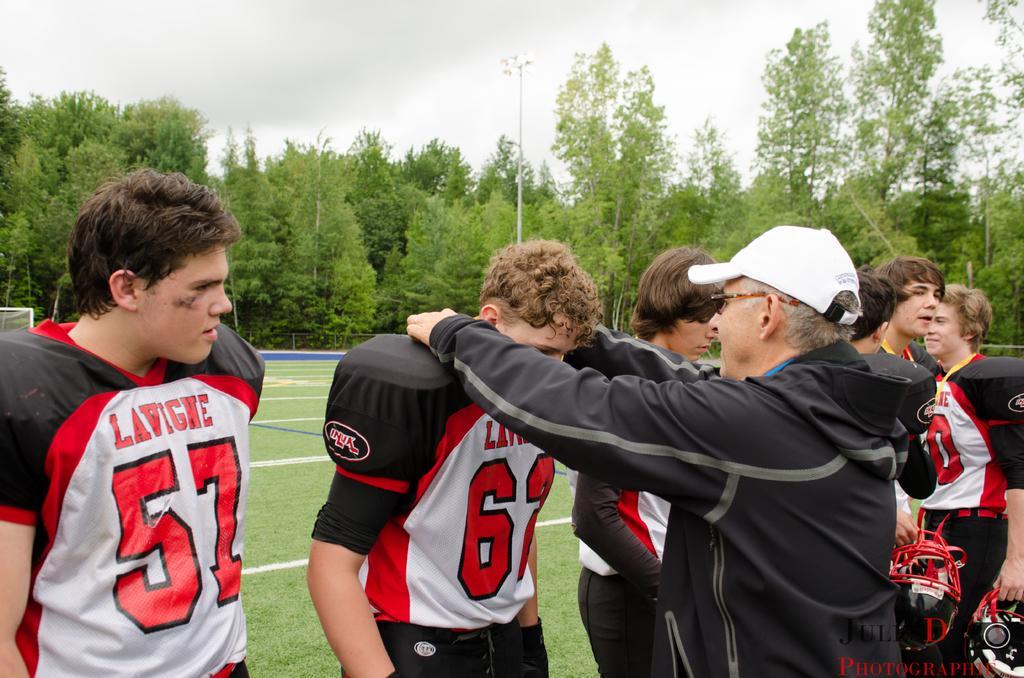How would you summarize this image in a sentence or two? There are some persons standing on the ground as we can see at the bottom of this image and there are some trees in the background. There is a sky at the top of this image. 